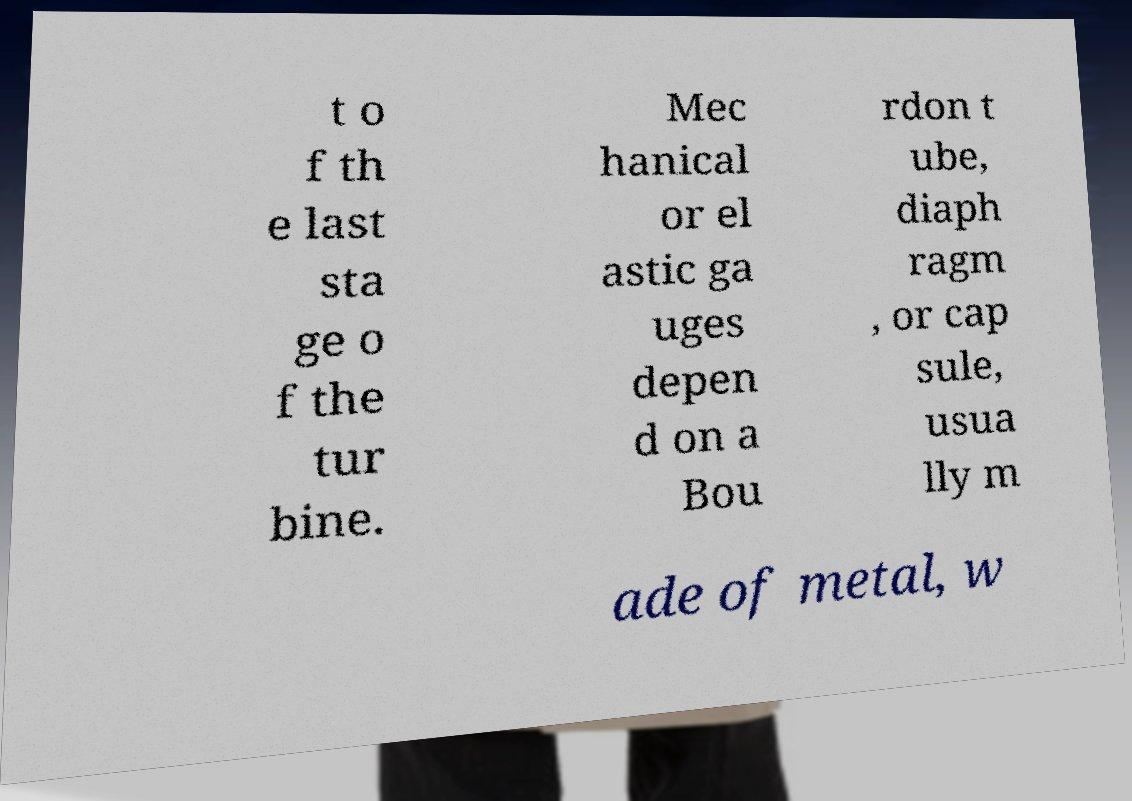What messages or text are displayed in this image? I need them in a readable, typed format. t o f th e last sta ge o f the tur bine. Mec hanical or el astic ga uges depen d on a Bou rdon t ube, diaph ragm , or cap sule, usua lly m ade of metal, w 